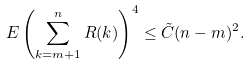<formula> <loc_0><loc_0><loc_500><loc_500>E \left ( \sum _ { k = m + 1 } ^ { n } R ( k ) \right ) ^ { 4 } \leq \tilde { C } ( n - m ) ^ { 2 } .</formula> 